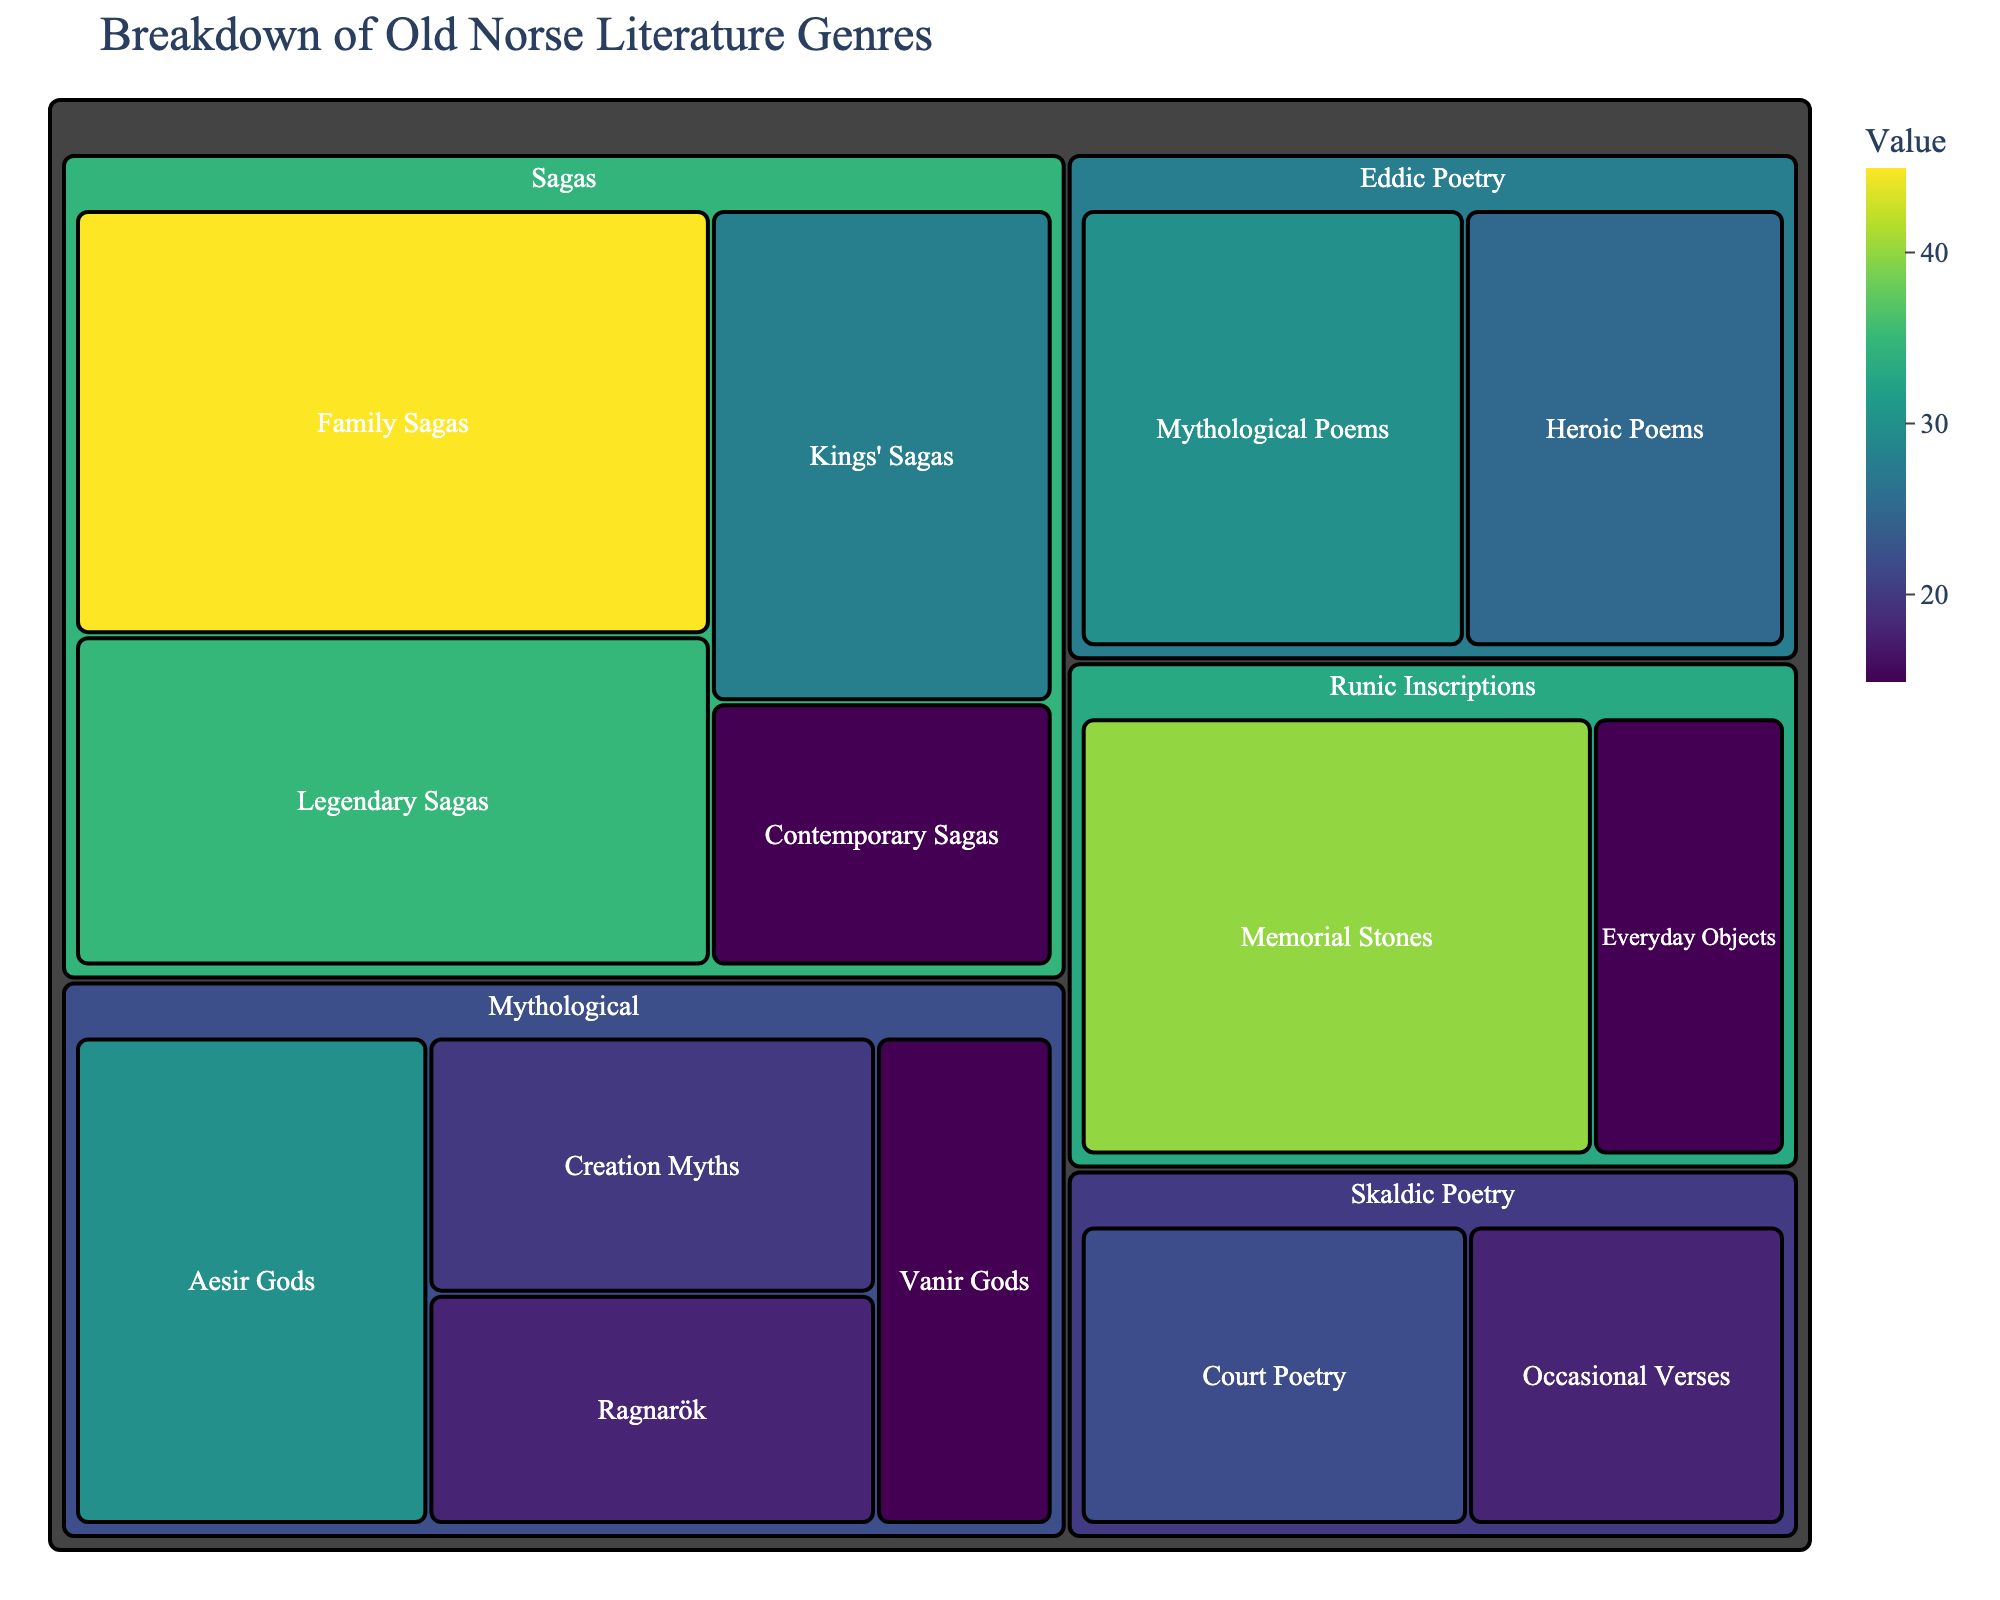What is the title of the treemap? The title of a figure is usually prominently displayed at the top. Here, it is "Breakdown of Old Norse Literature Genres".
Answer: Breakdown of Old Norse Literature Genres Which subcategory has the highest value in the "Sagas" category? Look at the "Sagas" category and compare the values for each subcategory. "Family Sagas" has the highest value of 45.
Answer: Family Sagas What is the total value of the "Mythological" category? Sum the values of all subcategories under "Mythological": Creation Myths (20), Ragnarök (18), Aesir Gods (30), Vanir Gods (15). The total is 20 + 18 + 30 + 15 = 83.
Answer: 83 Which category has more variety in subcategories, Sagas or Runic Inscriptions? Count the number of subcategories for each category. "Sagas" has 4 subcategories while "Runic Inscriptions" has 2.
Answer: Sagas Is the value of "Heroic Poems" greater than "Court Poetry"? Compare the values: "Heroic Poems" has a value of 25, while "Court Poetry" has 22.
Answer: Yes What is the difference between the values of "Legendary Sagas" and "Occasional Verses"? Subtract the value of "Occasional Verses" from "Legendary Sagas". 35 - 18 = 17.
Answer: 17 Which subcategory within "Eddic Poetry" has a higher value, "Heroic Poems" or "Mythological Poems"? Compare values within "Eddic Poetry": "Mythological Poems" has 30, which is greater than "Heroic Poems" with 25.
Answer: Mythological Poems What is the average value of subcategories within the "Sagas" category? Sum the values and divide by the number of subcategories: (35 + 28 + 45 + 15) / 4 = 30.75.
Answer: 30.75 How many subcategories have a value of 30 or higher? Identify subcategories with values ≥30: "Family Sagas" (45), "Aesir Gods" (30), "Mythological Poems" (30), "Memorial Stones" (40). Total is 4.
Answer: 4 Compare the total value of "Skaldic Poetry" to that of "Runic Inscriptions". Which is greater? Sum the values of "Skaldic Poetry" (22 + 18 = 40) and compare to "Runic Inscriptions" (40 + 15 = 55). "Runic Inscriptions" is greater.
Answer: Runic Inscriptions 